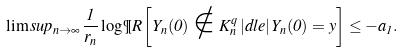Convert formula to latex. <formula><loc_0><loc_0><loc_500><loc_500>\lim s u p _ { n \rightarrow \infty } \frac { 1 } { r _ { n } } \log \P R \left [ Y _ { n } ( 0 ) \notin K _ { n } ^ { q } \, | d l e | \, Y _ { n } ( 0 ) = y \right ] \leq - a _ { 1 } .</formula> 